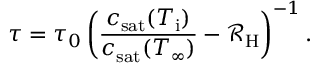<formula> <loc_0><loc_0><loc_500><loc_500>\tau = \tau _ { 0 } \left ( \frac { c _ { s a t } ( T _ { i } ) } { c _ { s a t } ( T _ { \infty } ) } - \mathcal { R } _ { H } \right ) ^ { - 1 } .</formula> 